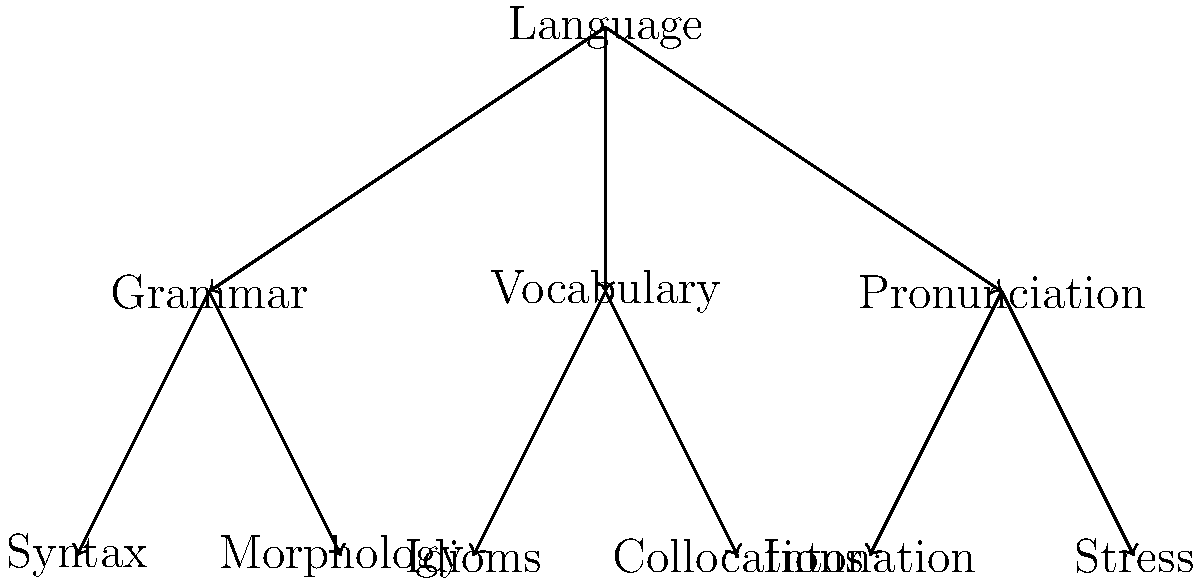As a language teacher emphasizing cohesiveness and coherence, analyze the given tree diagram representing the structure of language learning. Which element in the second level of the hierarchy contributes most directly to sentence-level coherence? To answer this question, let's break down the tree diagram and analyze each level:

1. The root node represents "Language" as the main topic.

2. The first level of the hierarchy includes three main branches:
   a) Grammar
   b) Vocabulary
   c) Pronunciation

3. The second level further breaks down these branches:
   a) Grammar: Syntax and Morphology
   b) Vocabulary: Idioms and Collocations
   c) Pronunciation: Intonation and Stress

4. For sentence-level coherence, we need to consider which element contributes most to the logical flow and connection between sentences.

5. Analyzing the second-level elements:
   - Syntax: Deals with sentence structure and word order
   - Morphology: Focuses on word formation and internal structure
   - Idioms: Set phrases with non-literal meanings
   - Collocations: Words that commonly occur together
   - Intonation: Variation in spoken pitch
   - Stress: Emphasis on certain syllables or words

6. Among these, syntax is most directly related to sentence-level coherence because it governs how words are arranged to form grammatically correct and meaningful sentences. Proper syntax ensures that ideas flow logically from one sentence to another, maintaining coherence in the text.

Therefore, the element in the second level of the hierarchy that contributes most directly to sentence-level coherence is syntax.
Answer: Syntax 